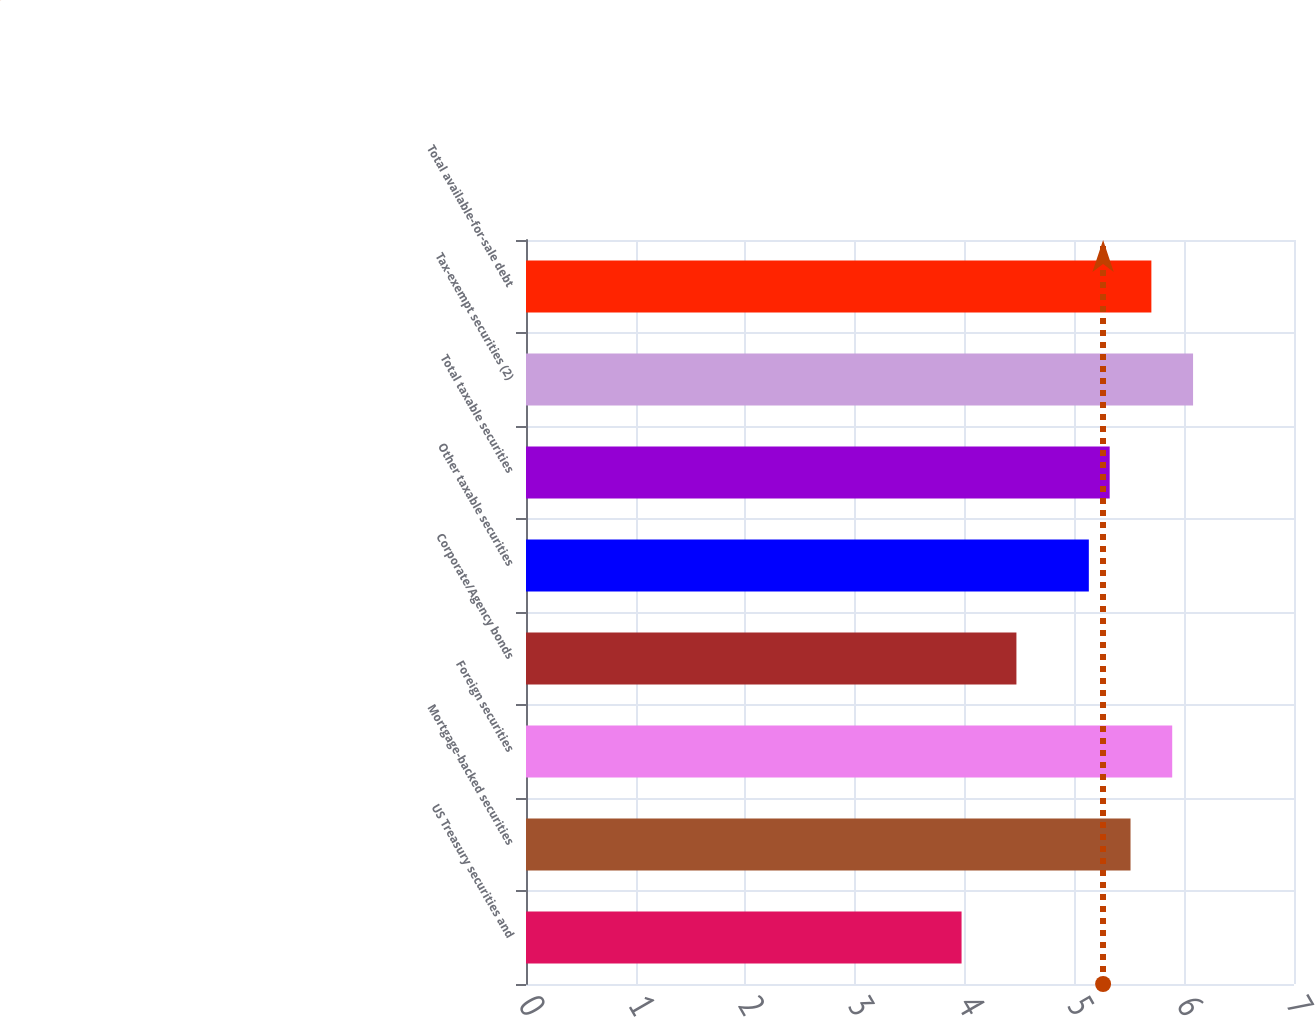Convert chart. <chart><loc_0><loc_0><loc_500><loc_500><bar_chart><fcel>US Treasury securities and<fcel>Mortgage-backed securities<fcel>Foreign securities<fcel>Corporate/Agency bonds<fcel>Other taxable securities<fcel>Total taxable securities<fcel>Tax-exempt securities (2)<fcel>Total available-for-sale debt<nl><fcel>3.97<fcel>5.51<fcel>5.89<fcel>4.47<fcel>5.13<fcel>5.32<fcel>6.08<fcel>5.7<nl></chart> 